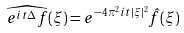<formula> <loc_0><loc_0><loc_500><loc_500>\widehat { e ^ { i t \Delta } f } ( \xi ) = e ^ { - 4 \pi ^ { 2 } i t | \xi | ^ { 2 } } \hat { f } ( \xi )</formula> 